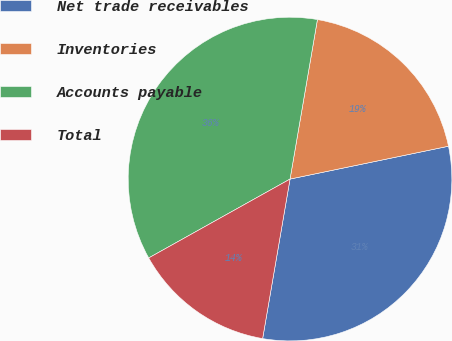Convert chart. <chart><loc_0><loc_0><loc_500><loc_500><pie_chart><fcel>Net trade receivables<fcel>Inventories<fcel>Accounts payable<fcel>Total<nl><fcel>30.96%<fcel>19.04%<fcel>35.81%<fcel>14.19%<nl></chart> 